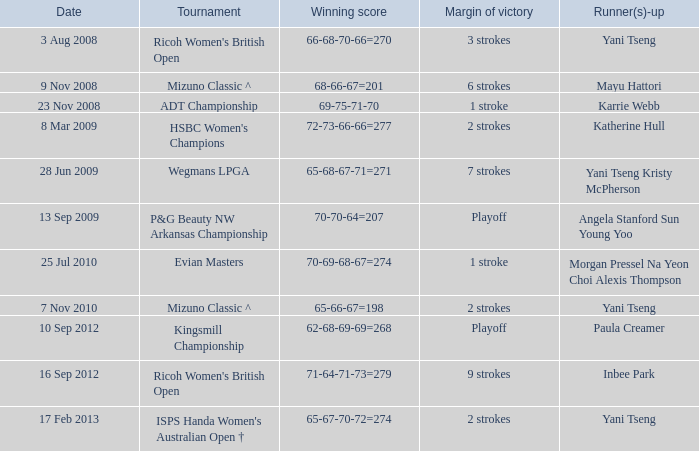What tournament had a victory of a 1 stroke margin and the final winning score 69-75-71-70? ADT Championship. 